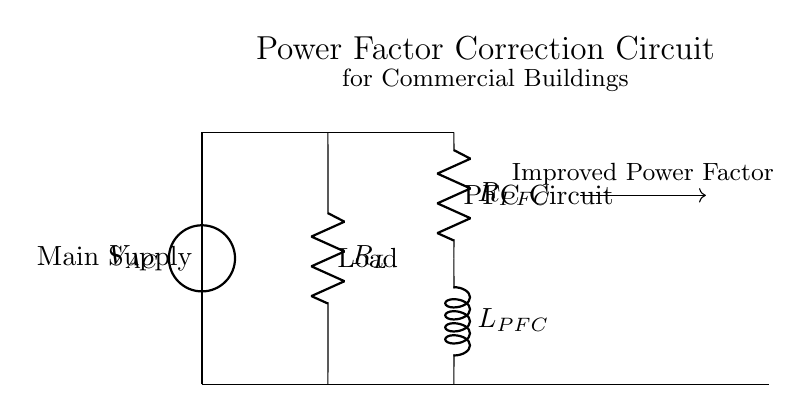What type of load is depicted in the circuit? The circuit shows a resistive load symbolized by the resistor labeled R_L, which typically represents an electrical load that consumes power without storing it.
Answer: Resistive What is the role of the R_PFC component in the circuit? R_PFC is a resistor that serves as a part of the power factor correction circuit, aiming to optimize the power factor by managing the phase difference between voltage and current.
Answer: Power factor correction Which component appears immediately after the voltage source? The first component connected after the voltage source is the resistor labeled R_L, which denotes the primary load receiving the electrical power.
Answer: R_L What is the purpose of the L_PFC in the circuit? L_PFC, an inductor connected in series with R_PFC, helps to adjust the impedance in the circuit, improving the overall power factor by creating a balancing effect against the reactive power.
Answer: Inductor How does the circuit improve the power factor? The circuit improves the power factor by incorporating the resistor and inductor in the PFC circuit which counteracts the lagging current typically caused by inductive loads, leading to better energy efficiency.
Answer: By reducing lagging current 